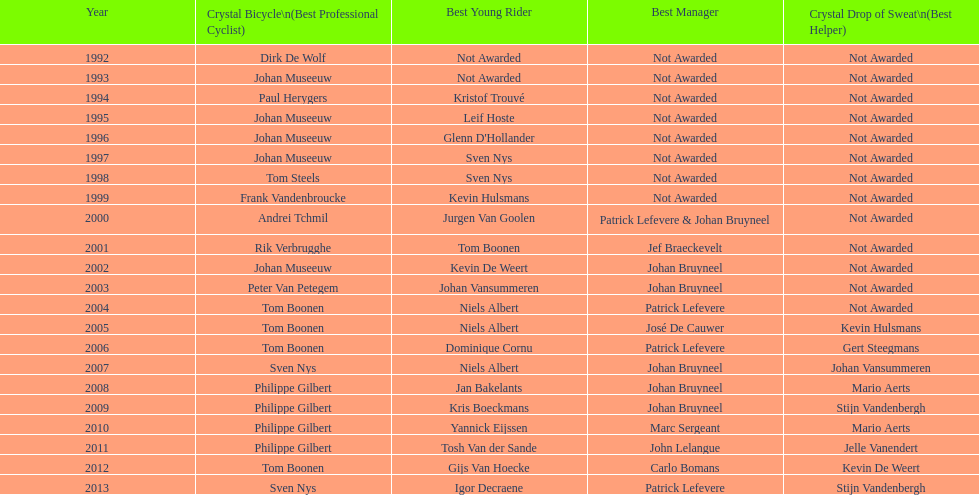Between boonen and nys, who previously secured the crystal bicycle victory? Tom Boonen. 